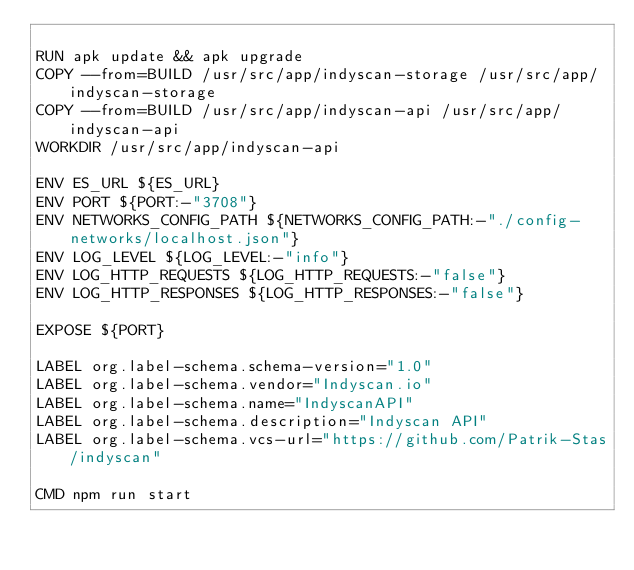Convert code to text. <code><loc_0><loc_0><loc_500><loc_500><_Dockerfile_>
RUN apk update && apk upgrade
COPY --from=BUILD /usr/src/app/indyscan-storage /usr/src/app/indyscan-storage
COPY --from=BUILD /usr/src/app/indyscan-api /usr/src/app/indyscan-api
WORKDIR /usr/src/app/indyscan-api

ENV ES_URL ${ES_URL}
ENV PORT ${PORT:-"3708"}
ENV NETWORKS_CONFIG_PATH ${NETWORKS_CONFIG_PATH:-"./config-networks/localhost.json"}
ENV LOG_LEVEL ${LOG_LEVEL:-"info"}
ENV LOG_HTTP_REQUESTS ${LOG_HTTP_REQUESTS:-"false"}
ENV LOG_HTTP_RESPONSES ${LOG_HTTP_RESPONSES:-"false"}

EXPOSE ${PORT}

LABEL org.label-schema.schema-version="1.0"
LABEL org.label-schema.vendor="Indyscan.io"
LABEL org.label-schema.name="IndyscanAPI"
LABEL org.label-schema.description="Indyscan API"
LABEL org.label-schema.vcs-url="https://github.com/Patrik-Stas/indyscan"

CMD npm run start
</code> 